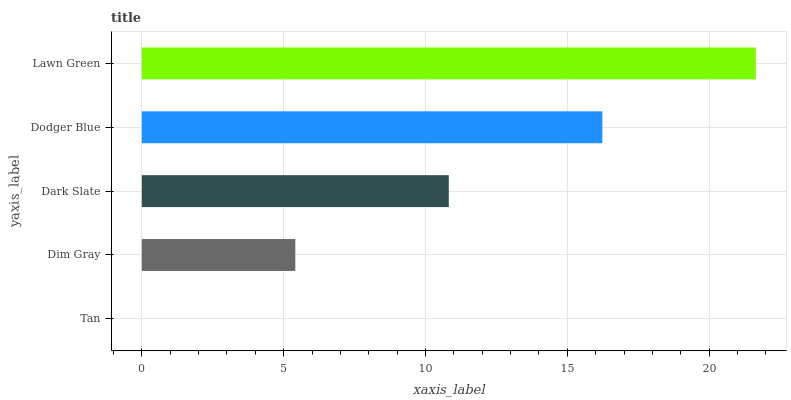Is Tan the minimum?
Answer yes or no. Yes. Is Lawn Green the maximum?
Answer yes or no. Yes. Is Dim Gray the minimum?
Answer yes or no. No. Is Dim Gray the maximum?
Answer yes or no. No. Is Dim Gray greater than Tan?
Answer yes or no. Yes. Is Tan less than Dim Gray?
Answer yes or no. Yes. Is Tan greater than Dim Gray?
Answer yes or no. No. Is Dim Gray less than Tan?
Answer yes or no. No. Is Dark Slate the high median?
Answer yes or no. Yes. Is Dark Slate the low median?
Answer yes or no. Yes. Is Tan the high median?
Answer yes or no. No. Is Tan the low median?
Answer yes or no. No. 